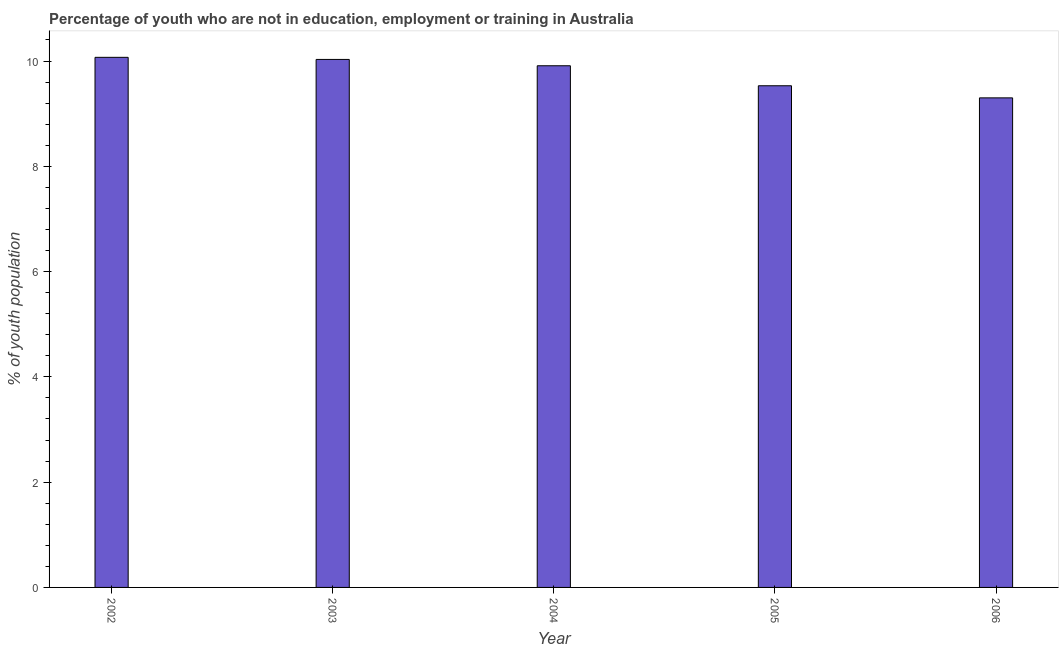Does the graph contain any zero values?
Keep it short and to the point. No. What is the title of the graph?
Keep it short and to the point. Percentage of youth who are not in education, employment or training in Australia. What is the label or title of the Y-axis?
Give a very brief answer. % of youth population. What is the unemployed youth population in 2004?
Your response must be concise. 9.91. Across all years, what is the maximum unemployed youth population?
Your response must be concise. 10.07. Across all years, what is the minimum unemployed youth population?
Make the answer very short. 9.3. In which year was the unemployed youth population maximum?
Your response must be concise. 2002. In which year was the unemployed youth population minimum?
Your answer should be very brief. 2006. What is the sum of the unemployed youth population?
Offer a terse response. 48.84. What is the difference between the unemployed youth population in 2005 and 2006?
Give a very brief answer. 0.23. What is the average unemployed youth population per year?
Offer a terse response. 9.77. What is the median unemployed youth population?
Provide a succinct answer. 9.91. Do a majority of the years between 2002 and 2004 (inclusive) have unemployed youth population greater than 3.2 %?
Provide a succinct answer. Yes. What is the ratio of the unemployed youth population in 2004 to that in 2006?
Offer a very short reply. 1.07. Is the difference between the unemployed youth population in 2003 and 2006 greater than the difference between any two years?
Provide a short and direct response. No. Is the sum of the unemployed youth population in 2002 and 2006 greater than the maximum unemployed youth population across all years?
Offer a terse response. Yes. What is the difference between the highest and the lowest unemployed youth population?
Ensure brevity in your answer.  0.77. In how many years, is the unemployed youth population greater than the average unemployed youth population taken over all years?
Give a very brief answer. 3. How many years are there in the graph?
Give a very brief answer. 5. Are the values on the major ticks of Y-axis written in scientific E-notation?
Ensure brevity in your answer.  No. What is the % of youth population of 2002?
Keep it short and to the point. 10.07. What is the % of youth population of 2003?
Provide a short and direct response. 10.03. What is the % of youth population of 2004?
Provide a short and direct response. 9.91. What is the % of youth population in 2005?
Your answer should be very brief. 9.53. What is the % of youth population in 2006?
Offer a very short reply. 9.3. What is the difference between the % of youth population in 2002 and 2004?
Provide a short and direct response. 0.16. What is the difference between the % of youth population in 2002 and 2005?
Offer a very short reply. 0.54. What is the difference between the % of youth population in 2002 and 2006?
Give a very brief answer. 0.77. What is the difference between the % of youth population in 2003 and 2004?
Make the answer very short. 0.12. What is the difference between the % of youth population in 2003 and 2006?
Keep it short and to the point. 0.73. What is the difference between the % of youth population in 2004 and 2005?
Ensure brevity in your answer.  0.38. What is the difference between the % of youth population in 2004 and 2006?
Offer a very short reply. 0.61. What is the difference between the % of youth population in 2005 and 2006?
Keep it short and to the point. 0.23. What is the ratio of the % of youth population in 2002 to that in 2003?
Provide a succinct answer. 1. What is the ratio of the % of youth population in 2002 to that in 2004?
Give a very brief answer. 1.02. What is the ratio of the % of youth population in 2002 to that in 2005?
Your answer should be very brief. 1.06. What is the ratio of the % of youth population in 2002 to that in 2006?
Offer a terse response. 1.08. What is the ratio of the % of youth population in 2003 to that in 2005?
Make the answer very short. 1.05. What is the ratio of the % of youth population in 2003 to that in 2006?
Make the answer very short. 1.08. What is the ratio of the % of youth population in 2004 to that in 2006?
Make the answer very short. 1.07. What is the ratio of the % of youth population in 2005 to that in 2006?
Provide a short and direct response. 1.02. 